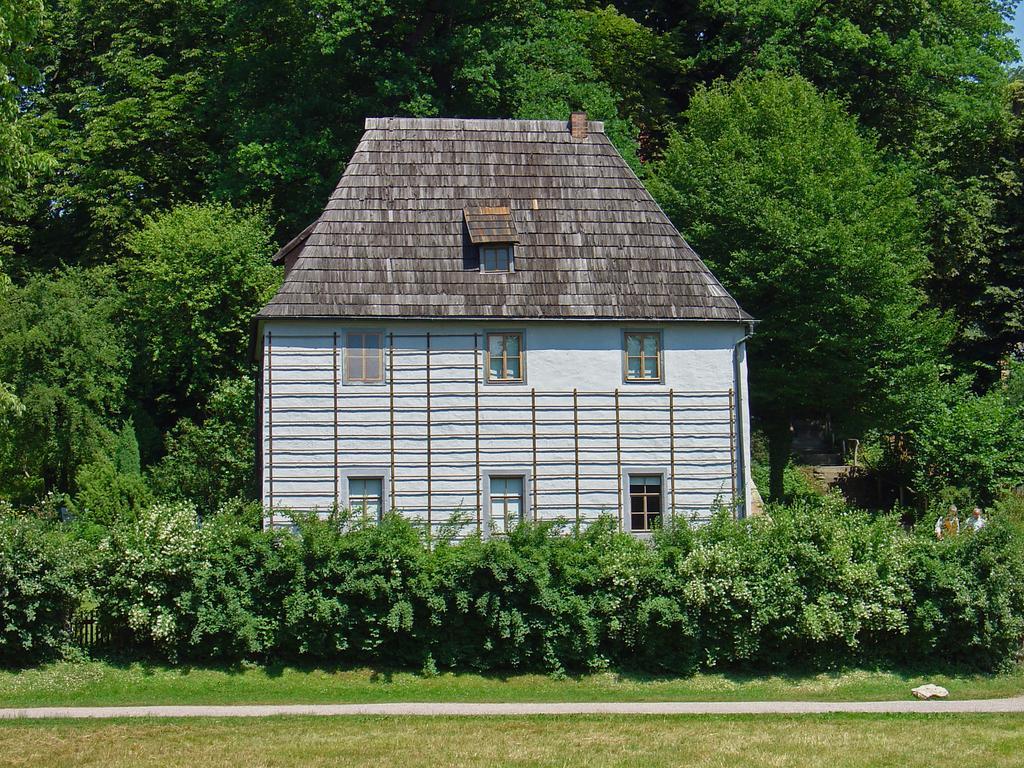Please provide a concise description of this image. In this image at the bottom I can see many grasses and in the middle I can see a house which is covered with trees and plants and the background is the sky. 